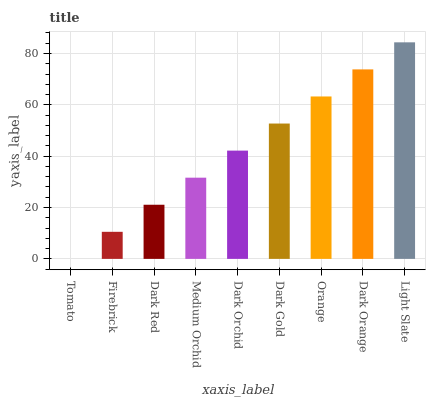Is Tomato the minimum?
Answer yes or no. Yes. Is Light Slate the maximum?
Answer yes or no. Yes. Is Firebrick the minimum?
Answer yes or no. No. Is Firebrick the maximum?
Answer yes or no. No. Is Firebrick greater than Tomato?
Answer yes or no. Yes. Is Tomato less than Firebrick?
Answer yes or no. Yes. Is Tomato greater than Firebrick?
Answer yes or no. No. Is Firebrick less than Tomato?
Answer yes or no. No. Is Dark Orchid the high median?
Answer yes or no. Yes. Is Dark Orchid the low median?
Answer yes or no. Yes. Is Orange the high median?
Answer yes or no. No. Is Light Slate the low median?
Answer yes or no. No. 